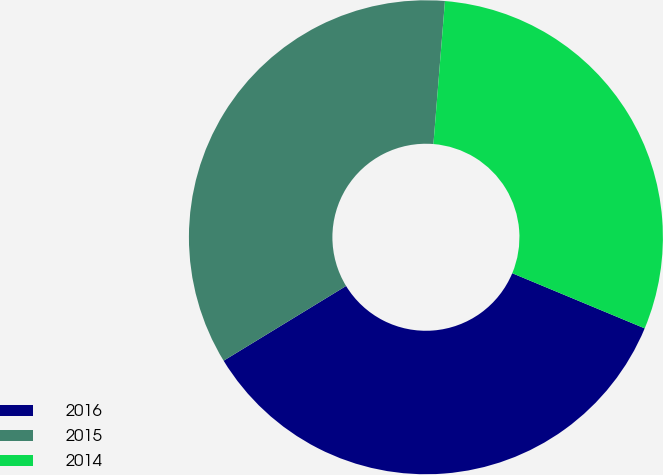Convert chart to OTSL. <chart><loc_0><loc_0><loc_500><loc_500><pie_chart><fcel>2016<fcel>2015<fcel>2014<nl><fcel>35.0%<fcel>35.0%<fcel>30.0%<nl></chart> 